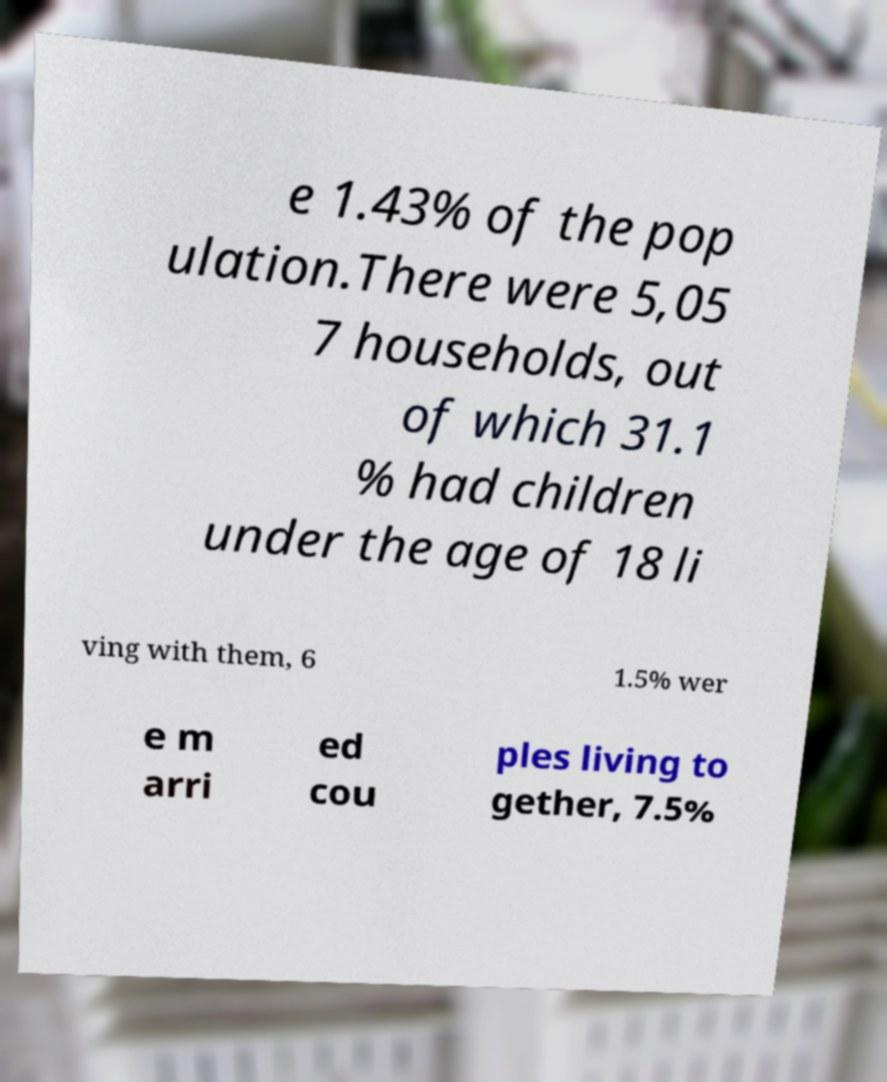Could you assist in decoding the text presented in this image and type it out clearly? e 1.43% of the pop ulation.There were 5,05 7 households, out of which 31.1 % had children under the age of 18 li ving with them, 6 1.5% wer e m arri ed cou ples living to gether, 7.5% 